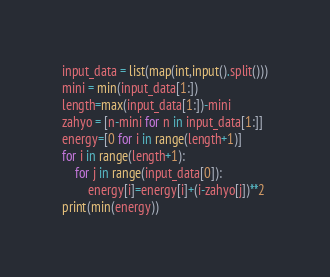<code> <loc_0><loc_0><loc_500><loc_500><_Python_>input_data = list(map(int,input().split()))
mini = min(input_data[1:])
length=max(input_data[1:])-mini
zahyo = [n-mini for n in input_data[1:]]
energy=[0 for i in range(length+1)]
for i in range(length+1):
    for j in range(input_data[0]):
        energy[i]=energy[i]+(i-zahyo[j])**2
print(min(energy))</code> 